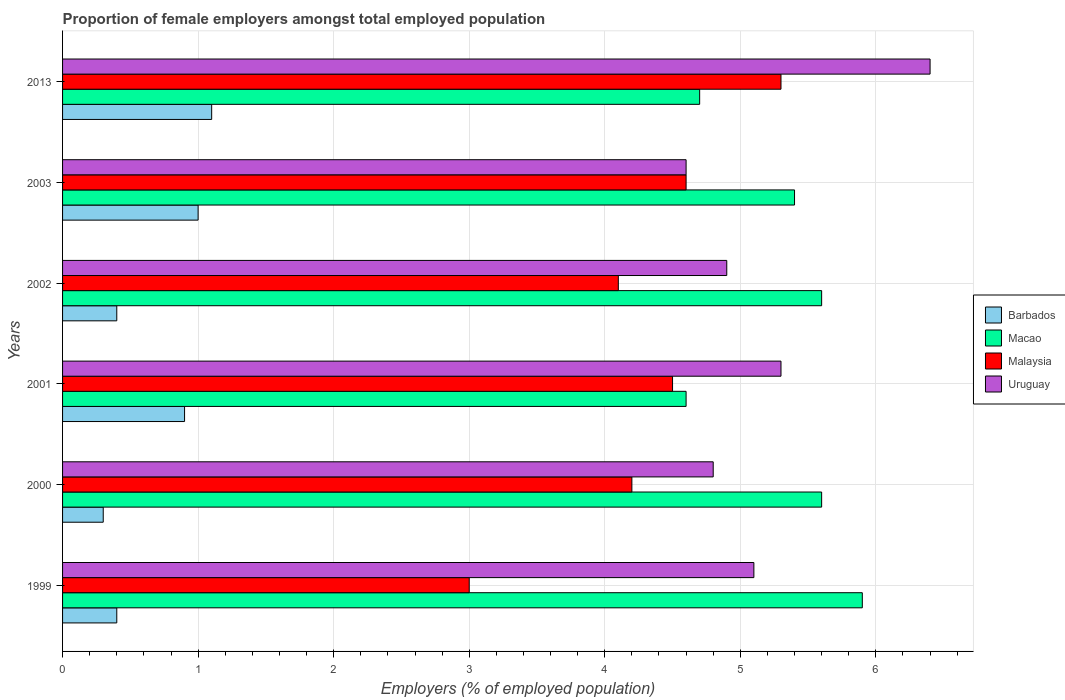How many groups of bars are there?
Offer a terse response. 6. Are the number of bars per tick equal to the number of legend labels?
Offer a very short reply. Yes. Are the number of bars on each tick of the Y-axis equal?
Make the answer very short. Yes. How many bars are there on the 4th tick from the top?
Your answer should be very brief. 4. What is the label of the 1st group of bars from the top?
Offer a very short reply. 2013. In how many cases, is the number of bars for a given year not equal to the number of legend labels?
Your response must be concise. 0. Across all years, what is the maximum proportion of female employers in Barbados?
Your answer should be compact. 1.1. Across all years, what is the minimum proportion of female employers in Barbados?
Your answer should be compact. 0.3. In which year was the proportion of female employers in Malaysia maximum?
Your answer should be very brief. 2013. What is the total proportion of female employers in Macao in the graph?
Provide a short and direct response. 31.8. What is the difference between the proportion of female employers in Malaysia in 2013 and the proportion of female employers in Macao in 2002?
Make the answer very short. -0.3. What is the average proportion of female employers in Macao per year?
Provide a short and direct response. 5.3. In the year 2001, what is the difference between the proportion of female employers in Malaysia and proportion of female employers in Macao?
Ensure brevity in your answer.  -0.1. In how many years, is the proportion of female employers in Malaysia greater than 0.2 %?
Your answer should be compact. 6. What is the ratio of the proportion of female employers in Barbados in 1999 to that in 2002?
Offer a very short reply. 1. What is the difference between the highest and the second highest proportion of female employers in Macao?
Ensure brevity in your answer.  0.3. What is the difference between the highest and the lowest proportion of female employers in Macao?
Provide a succinct answer. 1.3. In how many years, is the proportion of female employers in Uruguay greater than the average proportion of female employers in Uruguay taken over all years?
Keep it short and to the point. 2. Is the sum of the proportion of female employers in Malaysia in 2000 and 2001 greater than the maximum proportion of female employers in Uruguay across all years?
Your response must be concise. Yes. What does the 2nd bar from the top in 2003 represents?
Provide a short and direct response. Malaysia. What does the 1st bar from the bottom in 2000 represents?
Provide a succinct answer. Barbados. How many bars are there?
Keep it short and to the point. 24. Are all the bars in the graph horizontal?
Give a very brief answer. Yes. What is the difference between two consecutive major ticks on the X-axis?
Provide a short and direct response. 1. Are the values on the major ticks of X-axis written in scientific E-notation?
Offer a terse response. No. Does the graph contain grids?
Your response must be concise. Yes. Where does the legend appear in the graph?
Your answer should be compact. Center right. How many legend labels are there?
Provide a succinct answer. 4. What is the title of the graph?
Make the answer very short. Proportion of female employers amongst total employed population. What is the label or title of the X-axis?
Offer a very short reply. Employers (% of employed population). What is the label or title of the Y-axis?
Give a very brief answer. Years. What is the Employers (% of employed population) in Barbados in 1999?
Your answer should be compact. 0.4. What is the Employers (% of employed population) of Macao in 1999?
Your answer should be very brief. 5.9. What is the Employers (% of employed population) in Uruguay in 1999?
Offer a very short reply. 5.1. What is the Employers (% of employed population) in Barbados in 2000?
Provide a short and direct response. 0.3. What is the Employers (% of employed population) in Macao in 2000?
Keep it short and to the point. 5.6. What is the Employers (% of employed population) in Malaysia in 2000?
Your answer should be very brief. 4.2. What is the Employers (% of employed population) of Uruguay in 2000?
Offer a terse response. 4.8. What is the Employers (% of employed population) of Barbados in 2001?
Provide a short and direct response. 0.9. What is the Employers (% of employed population) in Macao in 2001?
Provide a short and direct response. 4.6. What is the Employers (% of employed population) in Malaysia in 2001?
Provide a succinct answer. 4.5. What is the Employers (% of employed population) of Uruguay in 2001?
Keep it short and to the point. 5.3. What is the Employers (% of employed population) of Barbados in 2002?
Give a very brief answer. 0.4. What is the Employers (% of employed population) of Macao in 2002?
Offer a very short reply. 5.6. What is the Employers (% of employed population) of Malaysia in 2002?
Your response must be concise. 4.1. What is the Employers (% of employed population) in Uruguay in 2002?
Keep it short and to the point. 4.9. What is the Employers (% of employed population) in Macao in 2003?
Your response must be concise. 5.4. What is the Employers (% of employed population) of Malaysia in 2003?
Make the answer very short. 4.6. What is the Employers (% of employed population) of Uruguay in 2003?
Your answer should be very brief. 4.6. What is the Employers (% of employed population) in Barbados in 2013?
Provide a short and direct response. 1.1. What is the Employers (% of employed population) of Macao in 2013?
Your answer should be compact. 4.7. What is the Employers (% of employed population) of Malaysia in 2013?
Your answer should be compact. 5.3. What is the Employers (% of employed population) in Uruguay in 2013?
Offer a very short reply. 6.4. Across all years, what is the maximum Employers (% of employed population) of Barbados?
Ensure brevity in your answer.  1.1. Across all years, what is the maximum Employers (% of employed population) in Macao?
Make the answer very short. 5.9. Across all years, what is the maximum Employers (% of employed population) in Malaysia?
Offer a terse response. 5.3. Across all years, what is the maximum Employers (% of employed population) of Uruguay?
Provide a succinct answer. 6.4. Across all years, what is the minimum Employers (% of employed population) of Barbados?
Make the answer very short. 0.3. Across all years, what is the minimum Employers (% of employed population) of Macao?
Your answer should be compact. 4.6. Across all years, what is the minimum Employers (% of employed population) of Malaysia?
Make the answer very short. 3. Across all years, what is the minimum Employers (% of employed population) of Uruguay?
Offer a terse response. 4.6. What is the total Employers (% of employed population) of Macao in the graph?
Provide a succinct answer. 31.8. What is the total Employers (% of employed population) in Malaysia in the graph?
Give a very brief answer. 25.7. What is the total Employers (% of employed population) of Uruguay in the graph?
Your answer should be compact. 31.1. What is the difference between the Employers (% of employed population) in Macao in 1999 and that in 2000?
Ensure brevity in your answer.  0.3. What is the difference between the Employers (% of employed population) of Malaysia in 1999 and that in 2000?
Offer a very short reply. -1.2. What is the difference between the Employers (% of employed population) in Uruguay in 1999 and that in 2000?
Your answer should be compact. 0.3. What is the difference between the Employers (% of employed population) of Barbados in 1999 and that in 2001?
Provide a succinct answer. -0.5. What is the difference between the Employers (% of employed population) of Malaysia in 1999 and that in 2001?
Your response must be concise. -1.5. What is the difference between the Employers (% of employed population) in Uruguay in 1999 and that in 2001?
Give a very brief answer. -0.2. What is the difference between the Employers (% of employed population) of Macao in 1999 and that in 2002?
Give a very brief answer. 0.3. What is the difference between the Employers (% of employed population) of Uruguay in 1999 and that in 2002?
Offer a very short reply. 0.2. What is the difference between the Employers (% of employed population) in Barbados in 1999 and that in 2013?
Provide a short and direct response. -0.7. What is the difference between the Employers (% of employed population) in Macao in 2000 and that in 2001?
Offer a very short reply. 1. What is the difference between the Employers (% of employed population) of Malaysia in 2000 and that in 2001?
Your answer should be very brief. -0.3. What is the difference between the Employers (% of employed population) in Uruguay in 2000 and that in 2001?
Your answer should be very brief. -0.5. What is the difference between the Employers (% of employed population) of Malaysia in 2000 and that in 2002?
Your answer should be very brief. 0.1. What is the difference between the Employers (% of employed population) in Uruguay in 2000 and that in 2002?
Ensure brevity in your answer.  -0.1. What is the difference between the Employers (% of employed population) in Barbados in 2000 and that in 2003?
Ensure brevity in your answer.  -0.7. What is the difference between the Employers (% of employed population) in Barbados in 2000 and that in 2013?
Provide a succinct answer. -0.8. What is the difference between the Employers (% of employed population) of Malaysia in 2000 and that in 2013?
Your response must be concise. -1.1. What is the difference between the Employers (% of employed population) in Uruguay in 2000 and that in 2013?
Your response must be concise. -1.6. What is the difference between the Employers (% of employed population) in Barbados in 2001 and that in 2003?
Ensure brevity in your answer.  -0.1. What is the difference between the Employers (% of employed population) in Malaysia in 2001 and that in 2013?
Offer a very short reply. -0.8. What is the difference between the Employers (% of employed population) in Uruguay in 2001 and that in 2013?
Provide a short and direct response. -1.1. What is the difference between the Employers (% of employed population) in Macao in 2002 and that in 2003?
Offer a terse response. 0.2. What is the difference between the Employers (% of employed population) of Malaysia in 2002 and that in 2003?
Offer a very short reply. -0.5. What is the difference between the Employers (% of employed population) of Uruguay in 2002 and that in 2003?
Offer a very short reply. 0.3. What is the difference between the Employers (% of employed population) of Malaysia in 2002 and that in 2013?
Keep it short and to the point. -1.2. What is the difference between the Employers (% of employed population) in Barbados in 2003 and that in 2013?
Give a very brief answer. -0.1. What is the difference between the Employers (% of employed population) of Macao in 2003 and that in 2013?
Your response must be concise. 0.7. What is the difference between the Employers (% of employed population) in Malaysia in 2003 and that in 2013?
Your response must be concise. -0.7. What is the difference between the Employers (% of employed population) of Uruguay in 2003 and that in 2013?
Give a very brief answer. -1.8. What is the difference between the Employers (% of employed population) in Barbados in 1999 and the Employers (% of employed population) in Macao in 2000?
Provide a short and direct response. -5.2. What is the difference between the Employers (% of employed population) of Macao in 1999 and the Employers (% of employed population) of Uruguay in 2000?
Provide a succinct answer. 1.1. What is the difference between the Employers (% of employed population) of Barbados in 1999 and the Employers (% of employed population) of Malaysia in 2001?
Your response must be concise. -4.1. What is the difference between the Employers (% of employed population) of Barbados in 1999 and the Employers (% of employed population) of Uruguay in 2001?
Offer a terse response. -4.9. What is the difference between the Employers (% of employed population) in Macao in 1999 and the Employers (% of employed population) in Malaysia in 2001?
Provide a succinct answer. 1.4. What is the difference between the Employers (% of employed population) in Macao in 1999 and the Employers (% of employed population) in Uruguay in 2001?
Ensure brevity in your answer.  0.6. What is the difference between the Employers (% of employed population) in Barbados in 1999 and the Employers (% of employed population) in Malaysia in 2002?
Provide a short and direct response. -3.7. What is the difference between the Employers (% of employed population) in Macao in 1999 and the Employers (% of employed population) in Uruguay in 2002?
Offer a terse response. 1. What is the difference between the Employers (% of employed population) in Barbados in 1999 and the Employers (% of employed population) in Malaysia in 2003?
Your answer should be compact. -4.2. What is the difference between the Employers (% of employed population) in Macao in 1999 and the Employers (% of employed population) in Malaysia in 2003?
Provide a short and direct response. 1.3. What is the difference between the Employers (% of employed population) of Barbados in 1999 and the Employers (% of employed population) of Macao in 2013?
Your response must be concise. -4.3. What is the difference between the Employers (% of employed population) of Barbados in 1999 and the Employers (% of employed population) of Uruguay in 2013?
Offer a terse response. -6. What is the difference between the Employers (% of employed population) in Macao in 1999 and the Employers (% of employed population) in Uruguay in 2013?
Provide a succinct answer. -0.5. What is the difference between the Employers (% of employed population) in Barbados in 2000 and the Employers (% of employed population) in Malaysia in 2001?
Give a very brief answer. -4.2. What is the difference between the Employers (% of employed population) in Barbados in 2000 and the Employers (% of employed population) in Uruguay in 2001?
Your response must be concise. -5. What is the difference between the Employers (% of employed population) of Macao in 2000 and the Employers (% of employed population) of Malaysia in 2001?
Your answer should be very brief. 1.1. What is the difference between the Employers (% of employed population) in Macao in 2000 and the Employers (% of employed population) in Uruguay in 2001?
Provide a succinct answer. 0.3. What is the difference between the Employers (% of employed population) of Malaysia in 2000 and the Employers (% of employed population) of Uruguay in 2001?
Your response must be concise. -1.1. What is the difference between the Employers (% of employed population) of Barbados in 2000 and the Employers (% of employed population) of Malaysia in 2002?
Give a very brief answer. -3.8. What is the difference between the Employers (% of employed population) of Macao in 2000 and the Employers (% of employed population) of Malaysia in 2002?
Keep it short and to the point. 1.5. What is the difference between the Employers (% of employed population) of Malaysia in 2000 and the Employers (% of employed population) of Uruguay in 2002?
Give a very brief answer. -0.7. What is the difference between the Employers (% of employed population) in Barbados in 2000 and the Employers (% of employed population) in Uruguay in 2003?
Give a very brief answer. -4.3. What is the difference between the Employers (% of employed population) in Macao in 2000 and the Employers (% of employed population) in Uruguay in 2003?
Make the answer very short. 1. What is the difference between the Employers (% of employed population) in Barbados in 2000 and the Employers (% of employed population) in Malaysia in 2013?
Your answer should be very brief. -5. What is the difference between the Employers (% of employed population) of Macao in 2000 and the Employers (% of employed population) of Uruguay in 2013?
Give a very brief answer. -0.8. What is the difference between the Employers (% of employed population) in Malaysia in 2000 and the Employers (% of employed population) in Uruguay in 2013?
Your answer should be compact. -2.2. What is the difference between the Employers (% of employed population) of Barbados in 2001 and the Employers (% of employed population) of Malaysia in 2002?
Ensure brevity in your answer.  -3.2. What is the difference between the Employers (% of employed population) of Barbados in 2001 and the Employers (% of employed population) of Uruguay in 2002?
Keep it short and to the point. -4. What is the difference between the Employers (% of employed population) of Malaysia in 2001 and the Employers (% of employed population) of Uruguay in 2002?
Keep it short and to the point. -0.4. What is the difference between the Employers (% of employed population) of Barbados in 2001 and the Employers (% of employed population) of Macao in 2003?
Your answer should be very brief. -4.5. What is the difference between the Employers (% of employed population) of Barbados in 2001 and the Employers (% of employed population) of Uruguay in 2003?
Offer a very short reply. -3.7. What is the difference between the Employers (% of employed population) in Macao in 2001 and the Employers (% of employed population) in Uruguay in 2003?
Your response must be concise. 0. What is the difference between the Employers (% of employed population) in Malaysia in 2001 and the Employers (% of employed population) in Uruguay in 2003?
Keep it short and to the point. -0.1. What is the difference between the Employers (% of employed population) of Barbados in 2001 and the Employers (% of employed population) of Malaysia in 2013?
Give a very brief answer. -4.4. What is the difference between the Employers (% of employed population) in Macao in 2001 and the Employers (% of employed population) in Malaysia in 2013?
Your answer should be very brief. -0.7. What is the difference between the Employers (% of employed population) of Barbados in 2002 and the Employers (% of employed population) of Macao in 2003?
Your answer should be very brief. -5. What is the difference between the Employers (% of employed population) of Barbados in 2002 and the Employers (% of employed population) of Uruguay in 2003?
Provide a short and direct response. -4.2. What is the difference between the Employers (% of employed population) in Macao in 2002 and the Employers (% of employed population) in Uruguay in 2003?
Provide a succinct answer. 1. What is the difference between the Employers (% of employed population) in Barbados in 2002 and the Employers (% of employed population) in Macao in 2013?
Keep it short and to the point. -4.3. What is the difference between the Employers (% of employed population) of Barbados in 2002 and the Employers (% of employed population) of Malaysia in 2013?
Provide a short and direct response. -4.9. What is the difference between the Employers (% of employed population) in Barbados in 2002 and the Employers (% of employed population) in Uruguay in 2013?
Provide a succinct answer. -6. What is the difference between the Employers (% of employed population) of Macao in 2002 and the Employers (% of employed population) of Uruguay in 2013?
Offer a very short reply. -0.8. What is the difference between the Employers (% of employed population) in Barbados in 2003 and the Employers (% of employed population) in Uruguay in 2013?
Your answer should be very brief. -5.4. What is the difference between the Employers (% of employed population) in Malaysia in 2003 and the Employers (% of employed population) in Uruguay in 2013?
Provide a succinct answer. -1.8. What is the average Employers (% of employed population) in Barbados per year?
Your answer should be compact. 0.68. What is the average Employers (% of employed population) of Macao per year?
Make the answer very short. 5.3. What is the average Employers (% of employed population) in Malaysia per year?
Make the answer very short. 4.28. What is the average Employers (% of employed population) in Uruguay per year?
Your answer should be compact. 5.18. In the year 1999, what is the difference between the Employers (% of employed population) of Barbados and Employers (% of employed population) of Macao?
Offer a terse response. -5.5. In the year 1999, what is the difference between the Employers (% of employed population) in Barbados and Employers (% of employed population) in Malaysia?
Make the answer very short. -2.6. In the year 1999, what is the difference between the Employers (% of employed population) of Barbados and Employers (% of employed population) of Uruguay?
Your response must be concise. -4.7. In the year 1999, what is the difference between the Employers (% of employed population) of Macao and Employers (% of employed population) of Uruguay?
Your response must be concise. 0.8. In the year 1999, what is the difference between the Employers (% of employed population) in Malaysia and Employers (% of employed population) in Uruguay?
Give a very brief answer. -2.1. In the year 2000, what is the difference between the Employers (% of employed population) in Barbados and Employers (% of employed population) in Macao?
Your answer should be very brief. -5.3. In the year 2000, what is the difference between the Employers (% of employed population) of Barbados and Employers (% of employed population) of Malaysia?
Give a very brief answer. -3.9. In the year 2000, what is the difference between the Employers (% of employed population) of Macao and Employers (% of employed population) of Malaysia?
Provide a succinct answer. 1.4. In the year 2001, what is the difference between the Employers (% of employed population) in Barbados and Employers (% of employed population) in Macao?
Provide a succinct answer. -3.7. In the year 2001, what is the difference between the Employers (% of employed population) in Barbados and Employers (% of employed population) in Malaysia?
Provide a short and direct response. -3.6. In the year 2001, what is the difference between the Employers (% of employed population) of Macao and Employers (% of employed population) of Uruguay?
Give a very brief answer. -0.7. In the year 2001, what is the difference between the Employers (% of employed population) of Malaysia and Employers (% of employed population) of Uruguay?
Provide a short and direct response. -0.8. In the year 2002, what is the difference between the Employers (% of employed population) in Barbados and Employers (% of employed population) in Malaysia?
Provide a short and direct response. -3.7. In the year 2002, what is the difference between the Employers (% of employed population) in Barbados and Employers (% of employed population) in Uruguay?
Your answer should be compact. -4.5. In the year 2002, what is the difference between the Employers (% of employed population) in Macao and Employers (% of employed population) in Uruguay?
Offer a very short reply. 0.7. In the year 2003, what is the difference between the Employers (% of employed population) in Barbados and Employers (% of employed population) in Malaysia?
Ensure brevity in your answer.  -3.6. In the year 2003, what is the difference between the Employers (% of employed population) of Malaysia and Employers (% of employed population) of Uruguay?
Your answer should be compact. 0. In the year 2013, what is the difference between the Employers (% of employed population) of Macao and Employers (% of employed population) of Malaysia?
Provide a short and direct response. -0.6. In the year 2013, what is the difference between the Employers (% of employed population) of Malaysia and Employers (% of employed population) of Uruguay?
Offer a very short reply. -1.1. What is the ratio of the Employers (% of employed population) of Barbados in 1999 to that in 2000?
Your answer should be compact. 1.33. What is the ratio of the Employers (% of employed population) in Macao in 1999 to that in 2000?
Offer a terse response. 1.05. What is the ratio of the Employers (% of employed population) of Malaysia in 1999 to that in 2000?
Offer a terse response. 0.71. What is the ratio of the Employers (% of employed population) in Barbados in 1999 to that in 2001?
Provide a succinct answer. 0.44. What is the ratio of the Employers (% of employed population) of Macao in 1999 to that in 2001?
Provide a short and direct response. 1.28. What is the ratio of the Employers (% of employed population) of Malaysia in 1999 to that in 2001?
Offer a terse response. 0.67. What is the ratio of the Employers (% of employed population) of Uruguay in 1999 to that in 2001?
Offer a terse response. 0.96. What is the ratio of the Employers (% of employed population) in Macao in 1999 to that in 2002?
Your answer should be compact. 1.05. What is the ratio of the Employers (% of employed population) of Malaysia in 1999 to that in 2002?
Provide a succinct answer. 0.73. What is the ratio of the Employers (% of employed population) of Uruguay in 1999 to that in 2002?
Give a very brief answer. 1.04. What is the ratio of the Employers (% of employed population) in Macao in 1999 to that in 2003?
Offer a very short reply. 1.09. What is the ratio of the Employers (% of employed population) of Malaysia in 1999 to that in 2003?
Keep it short and to the point. 0.65. What is the ratio of the Employers (% of employed population) of Uruguay in 1999 to that in 2003?
Make the answer very short. 1.11. What is the ratio of the Employers (% of employed population) in Barbados in 1999 to that in 2013?
Your answer should be compact. 0.36. What is the ratio of the Employers (% of employed population) in Macao in 1999 to that in 2013?
Keep it short and to the point. 1.26. What is the ratio of the Employers (% of employed population) of Malaysia in 1999 to that in 2013?
Your response must be concise. 0.57. What is the ratio of the Employers (% of employed population) of Uruguay in 1999 to that in 2013?
Your answer should be very brief. 0.8. What is the ratio of the Employers (% of employed population) in Barbados in 2000 to that in 2001?
Give a very brief answer. 0.33. What is the ratio of the Employers (% of employed population) of Macao in 2000 to that in 2001?
Your answer should be compact. 1.22. What is the ratio of the Employers (% of employed population) of Uruguay in 2000 to that in 2001?
Ensure brevity in your answer.  0.91. What is the ratio of the Employers (% of employed population) in Barbados in 2000 to that in 2002?
Your answer should be compact. 0.75. What is the ratio of the Employers (% of employed population) in Macao in 2000 to that in 2002?
Give a very brief answer. 1. What is the ratio of the Employers (% of employed population) in Malaysia in 2000 to that in 2002?
Offer a very short reply. 1.02. What is the ratio of the Employers (% of employed population) in Uruguay in 2000 to that in 2002?
Keep it short and to the point. 0.98. What is the ratio of the Employers (% of employed population) of Barbados in 2000 to that in 2003?
Provide a short and direct response. 0.3. What is the ratio of the Employers (% of employed population) in Malaysia in 2000 to that in 2003?
Provide a succinct answer. 0.91. What is the ratio of the Employers (% of employed population) of Uruguay in 2000 to that in 2003?
Your answer should be very brief. 1.04. What is the ratio of the Employers (% of employed population) in Barbados in 2000 to that in 2013?
Make the answer very short. 0.27. What is the ratio of the Employers (% of employed population) in Macao in 2000 to that in 2013?
Your response must be concise. 1.19. What is the ratio of the Employers (% of employed population) in Malaysia in 2000 to that in 2013?
Give a very brief answer. 0.79. What is the ratio of the Employers (% of employed population) of Uruguay in 2000 to that in 2013?
Offer a terse response. 0.75. What is the ratio of the Employers (% of employed population) of Barbados in 2001 to that in 2002?
Make the answer very short. 2.25. What is the ratio of the Employers (% of employed population) of Macao in 2001 to that in 2002?
Offer a terse response. 0.82. What is the ratio of the Employers (% of employed population) in Malaysia in 2001 to that in 2002?
Give a very brief answer. 1.1. What is the ratio of the Employers (% of employed population) of Uruguay in 2001 to that in 2002?
Your answer should be very brief. 1.08. What is the ratio of the Employers (% of employed population) in Barbados in 2001 to that in 2003?
Provide a succinct answer. 0.9. What is the ratio of the Employers (% of employed population) in Macao in 2001 to that in 2003?
Give a very brief answer. 0.85. What is the ratio of the Employers (% of employed population) in Malaysia in 2001 to that in 2003?
Offer a terse response. 0.98. What is the ratio of the Employers (% of employed population) in Uruguay in 2001 to that in 2003?
Give a very brief answer. 1.15. What is the ratio of the Employers (% of employed population) in Barbados in 2001 to that in 2013?
Offer a terse response. 0.82. What is the ratio of the Employers (% of employed population) of Macao in 2001 to that in 2013?
Provide a succinct answer. 0.98. What is the ratio of the Employers (% of employed population) of Malaysia in 2001 to that in 2013?
Ensure brevity in your answer.  0.85. What is the ratio of the Employers (% of employed population) of Uruguay in 2001 to that in 2013?
Your answer should be very brief. 0.83. What is the ratio of the Employers (% of employed population) of Macao in 2002 to that in 2003?
Your answer should be compact. 1.04. What is the ratio of the Employers (% of employed population) in Malaysia in 2002 to that in 2003?
Keep it short and to the point. 0.89. What is the ratio of the Employers (% of employed population) of Uruguay in 2002 to that in 2003?
Offer a terse response. 1.07. What is the ratio of the Employers (% of employed population) in Barbados in 2002 to that in 2013?
Ensure brevity in your answer.  0.36. What is the ratio of the Employers (% of employed population) of Macao in 2002 to that in 2013?
Your answer should be compact. 1.19. What is the ratio of the Employers (% of employed population) of Malaysia in 2002 to that in 2013?
Offer a terse response. 0.77. What is the ratio of the Employers (% of employed population) of Uruguay in 2002 to that in 2013?
Make the answer very short. 0.77. What is the ratio of the Employers (% of employed population) in Barbados in 2003 to that in 2013?
Ensure brevity in your answer.  0.91. What is the ratio of the Employers (% of employed population) of Macao in 2003 to that in 2013?
Give a very brief answer. 1.15. What is the ratio of the Employers (% of employed population) in Malaysia in 2003 to that in 2013?
Offer a terse response. 0.87. What is the ratio of the Employers (% of employed population) of Uruguay in 2003 to that in 2013?
Your answer should be compact. 0.72. What is the difference between the highest and the second highest Employers (% of employed population) in Macao?
Your answer should be very brief. 0.3. What is the difference between the highest and the second highest Employers (% of employed population) of Malaysia?
Provide a succinct answer. 0.7. What is the difference between the highest and the second highest Employers (% of employed population) of Uruguay?
Make the answer very short. 1.1. What is the difference between the highest and the lowest Employers (% of employed population) in Barbados?
Give a very brief answer. 0.8. What is the difference between the highest and the lowest Employers (% of employed population) in Macao?
Offer a terse response. 1.3. What is the difference between the highest and the lowest Employers (% of employed population) in Malaysia?
Your response must be concise. 2.3. What is the difference between the highest and the lowest Employers (% of employed population) in Uruguay?
Offer a terse response. 1.8. 